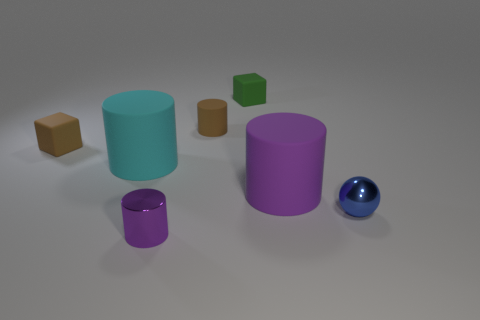What is the shape of the large object right of the tiny matte cube that is behind the brown rubber cube?
Provide a succinct answer. Cylinder. Are there any tiny purple metallic cylinders on the right side of the tiny brown cylinder?
Offer a terse response. No. What is the color of the metallic object that is the same size as the blue ball?
Your answer should be compact. Purple. How many large cyan things have the same material as the large purple cylinder?
Give a very brief answer. 1. How many other things are the same size as the cyan cylinder?
Your answer should be very brief. 1. Is there a blue object of the same size as the purple metal cylinder?
Offer a terse response. Yes. Do the big object in front of the cyan rubber object and the metallic sphere have the same color?
Keep it short and to the point. No. How many things are either small shiny balls or matte things?
Offer a terse response. 6. Is the size of the purple cylinder to the right of the purple metal cylinder the same as the tiny green object?
Your answer should be very brief. No. There is a rubber cylinder that is in front of the small matte cylinder and to the left of the green thing; what size is it?
Offer a terse response. Large. 